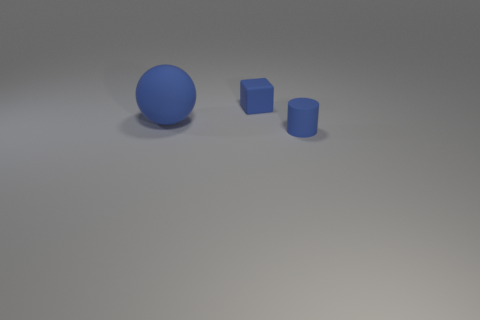Subtract all cylinders. How many objects are left? 2 Add 3 green matte things. How many green matte things exist? 3 Add 2 balls. How many objects exist? 5 Subtract 0 green balls. How many objects are left? 3 Subtract all small blocks. Subtract all matte cubes. How many objects are left? 1 Add 3 large blue rubber spheres. How many large blue rubber spheres are left? 4 